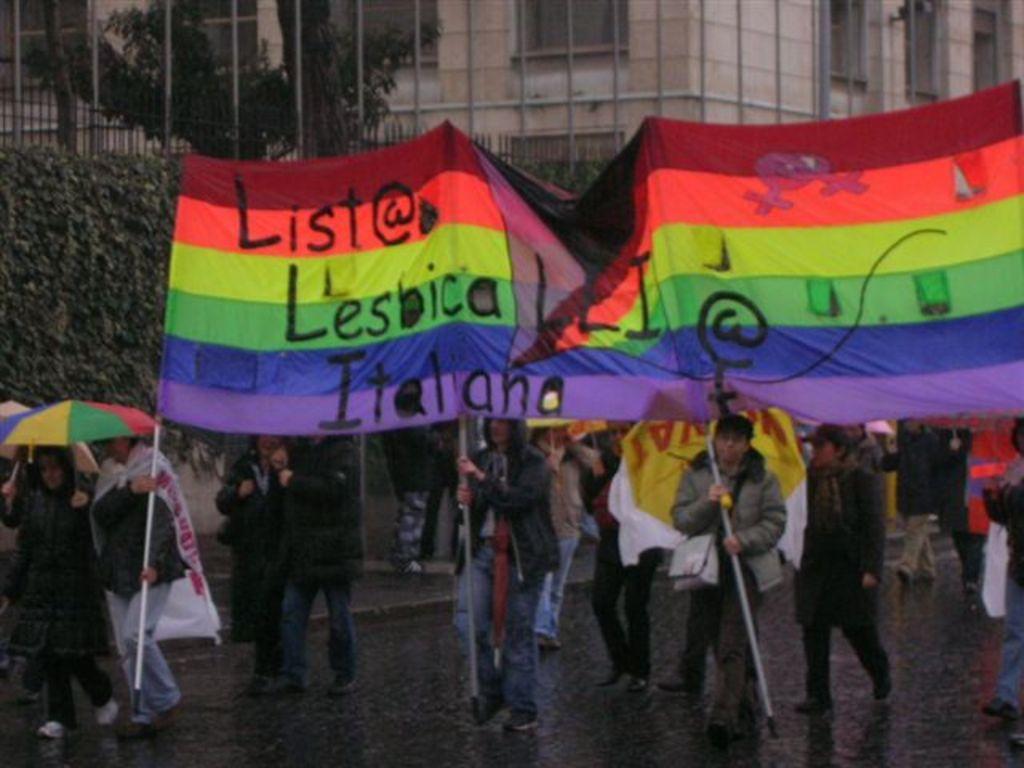Could you give a brief overview of what you see in this image? In this image I can see in the middle few people are standing by holding these clothes. On the left side a person is walking, this person wore coat and an umbrella and there are creepers and trees. At the back side there is a building. 